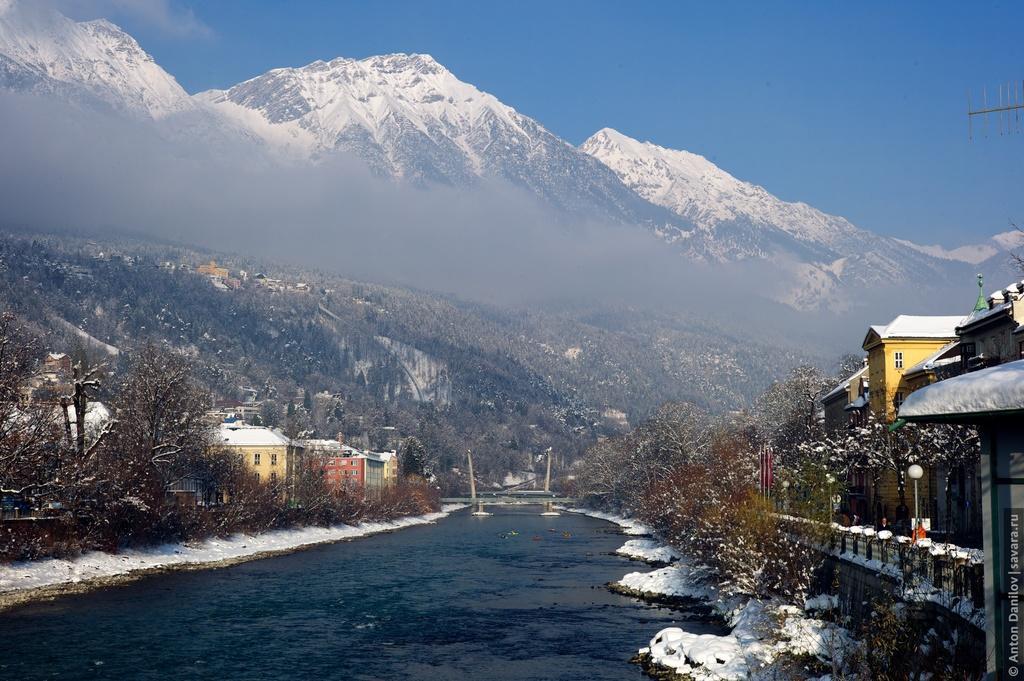In one or two sentences, can you explain what this image depicts? In this image I can see few buildings, windows, trees, light poles, snow, water, bridge and mountains. The sky is in blue color. 